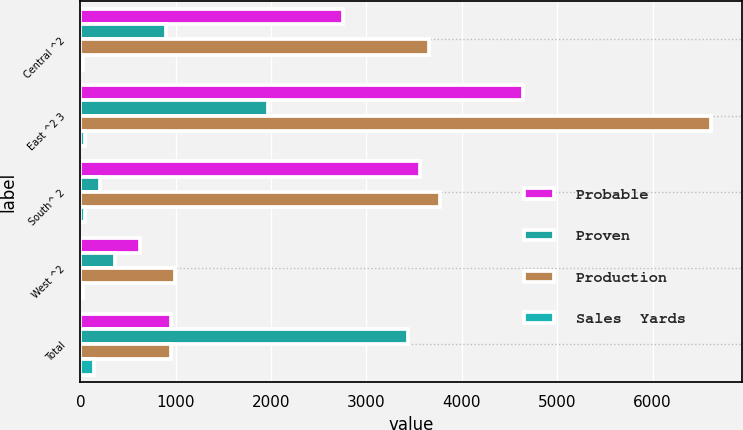<chart> <loc_0><loc_0><loc_500><loc_500><stacked_bar_chart><ecel><fcel>Central ^2<fcel>East ^2 3<fcel>South^ 2<fcel>West ^2<fcel>Total<nl><fcel>Probable<fcel>2753.7<fcel>4642.1<fcel>3566.4<fcel>628.2<fcel>945.65<nl><fcel>Proven<fcel>899.1<fcel>1966.9<fcel>200.8<fcel>364<fcel>3430.8<nl><fcel>Production<fcel>3652.8<fcel>6609<fcel>3767.2<fcel>992.2<fcel>945.65<nl><fcel>Sales  Yards<fcel>24.3<fcel>47.3<fcel>48.4<fcel>25<fcel>145<nl></chart> 